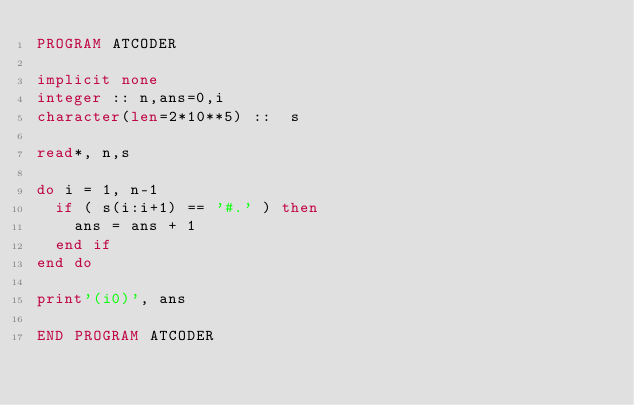<code> <loc_0><loc_0><loc_500><loc_500><_FORTRAN_>PROGRAM ATCODER

implicit none
integer :: n,ans=0,i
character(len=2*10**5) ::  s

read*, n,s

do i = 1, n-1
  if ( s(i:i+1) == '#.' ) then
    ans = ans + 1
  end if
end do

print'(i0)', ans

END PROGRAM ATCODER</code> 